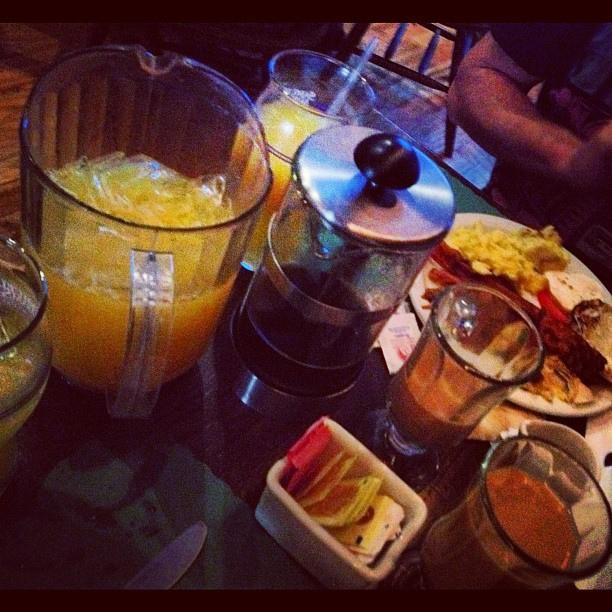How many wine glasses are there?
Give a very brief answer. 2. How many cakes are there?
Give a very brief answer. 2. How many knives are in the picture?
Give a very brief answer. 1. How many cups are in the picture?
Give a very brief answer. 4. How many pizzas are in this picture?
Give a very brief answer. 0. 